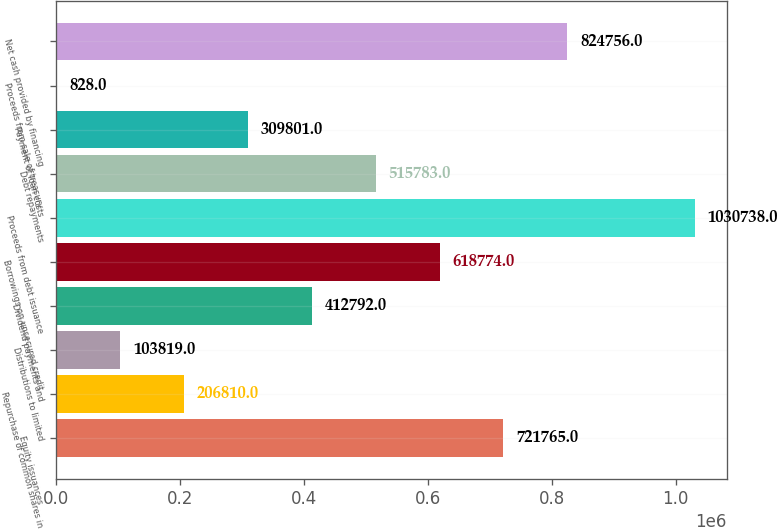Convert chart. <chart><loc_0><loc_0><loc_500><loc_500><bar_chart><fcel>Equity issuances<fcel>Repurchase of common shares in<fcel>Distributions to limited<fcel>Dividend payments and<fcel>Borrowings on unsecured credit<fcel>Proceeds from debt issuance<fcel>Debt repayments<fcel>Payment of loan costs<fcel>Proceeds from sale of treasury<fcel>Net cash provided by financing<nl><fcel>721765<fcel>206810<fcel>103819<fcel>412792<fcel>618774<fcel>1.03074e+06<fcel>515783<fcel>309801<fcel>828<fcel>824756<nl></chart> 